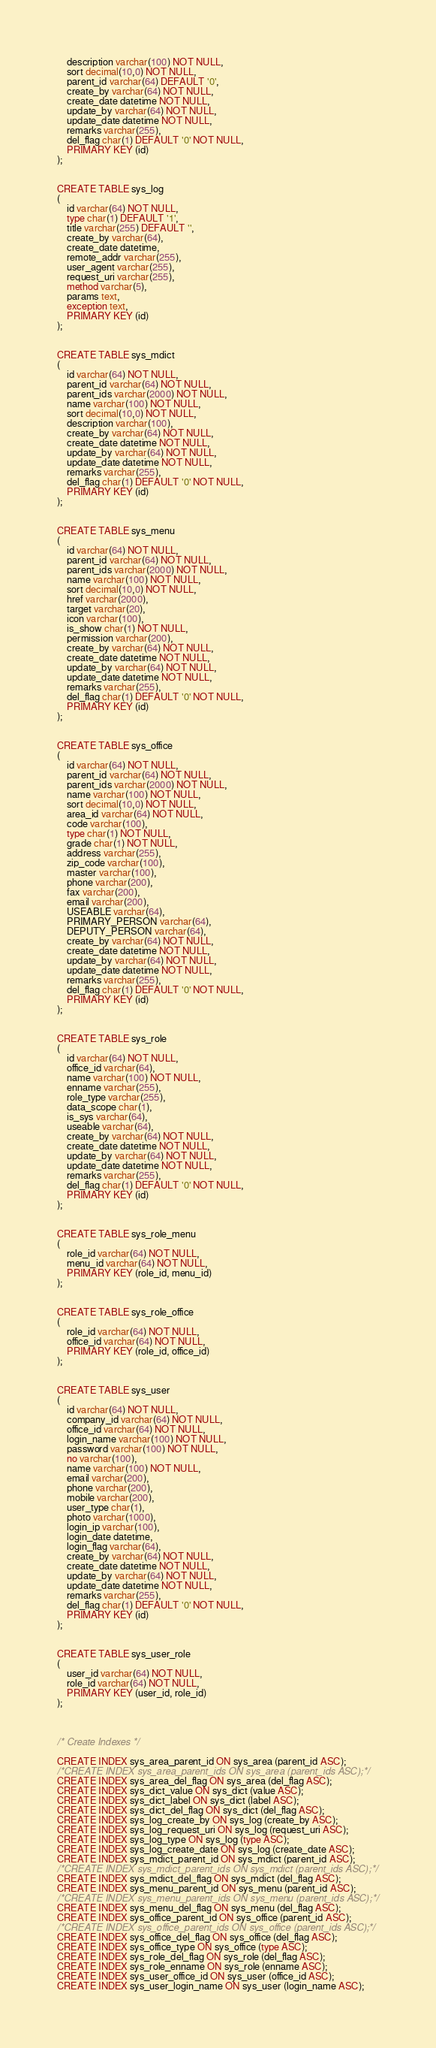<code> <loc_0><loc_0><loc_500><loc_500><_SQL_>	description varchar(100) NOT NULL,
	sort decimal(10,0) NOT NULL,
	parent_id varchar(64) DEFAULT '0',
	create_by varchar(64) NOT NULL,
	create_date datetime NOT NULL,
	update_by varchar(64) NOT NULL,
	update_date datetime NOT NULL,
	remarks varchar(255),
	del_flag char(1) DEFAULT '0' NOT NULL,
	PRIMARY KEY (id)
);


CREATE TABLE sys_log
(
	id varchar(64) NOT NULL,
	type char(1) DEFAULT '1',
	title varchar(255) DEFAULT '',
	create_by varchar(64),
	create_date datetime,
	remote_addr varchar(255),
	user_agent varchar(255),
	request_uri varchar(255),
	method varchar(5),
	params text,
	exception text,
	PRIMARY KEY (id)
);


CREATE TABLE sys_mdict
(
	id varchar(64) NOT NULL,
	parent_id varchar(64) NOT NULL,
	parent_ids varchar(2000) NOT NULL,
	name varchar(100) NOT NULL,
	sort decimal(10,0) NOT NULL,
	description varchar(100),
	create_by varchar(64) NOT NULL,
	create_date datetime NOT NULL,
	update_by varchar(64) NOT NULL,
	update_date datetime NOT NULL,
	remarks varchar(255),
	del_flag char(1) DEFAULT '0' NOT NULL,
	PRIMARY KEY (id)
);


CREATE TABLE sys_menu
(
	id varchar(64) NOT NULL,
	parent_id varchar(64) NOT NULL,
	parent_ids varchar(2000) NOT NULL,
	name varchar(100) NOT NULL,
	sort decimal(10,0) NOT NULL,
	href varchar(2000),
	target varchar(20),
	icon varchar(100),
	is_show char(1) NOT NULL,
	permission varchar(200),
	create_by varchar(64) NOT NULL,
	create_date datetime NOT NULL,
	update_by varchar(64) NOT NULL,
	update_date datetime NOT NULL,
	remarks varchar(255),
	del_flag char(1) DEFAULT '0' NOT NULL,
	PRIMARY KEY (id)
);


CREATE TABLE sys_office
(
	id varchar(64) NOT NULL,
	parent_id varchar(64) NOT NULL,
	parent_ids varchar(2000) NOT NULL,
	name varchar(100) NOT NULL,
	sort decimal(10,0) NOT NULL,
	area_id varchar(64) NOT NULL,
	code varchar(100),
	type char(1) NOT NULL,
	grade char(1) NOT NULL,
	address varchar(255),
	zip_code varchar(100),
	master varchar(100),
	phone varchar(200),
	fax varchar(200),
	email varchar(200),
	USEABLE varchar(64),
	PRIMARY_PERSON varchar(64),
	DEPUTY_PERSON varchar(64),
	create_by varchar(64) NOT NULL,
	create_date datetime NOT NULL,
	update_by varchar(64) NOT NULL,
	update_date datetime NOT NULL,
	remarks varchar(255),
	del_flag char(1) DEFAULT '0' NOT NULL,
	PRIMARY KEY (id)
);


CREATE TABLE sys_role
(
	id varchar(64) NOT NULL,
	office_id varchar(64),
	name varchar(100) NOT NULL,
	enname varchar(255),
	role_type varchar(255),
	data_scope char(1),
	is_sys varchar(64),
	useable varchar(64),
	create_by varchar(64) NOT NULL,
	create_date datetime NOT NULL,
	update_by varchar(64) NOT NULL,
	update_date datetime NOT NULL,
	remarks varchar(255),
	del_flag char(1) DEFAULT '0' NOT NULL,
	PRIMARY KEY (id)
);


CREATE TABLE sys_role_menu
(
	role_id varchar(64) NOT NULL,
	menu_id varchar(64) NOT NULL,
	PRIMARY KEY (role_id, menu_id)
);


CREATE TABLE sys_role_office
(
	role_id varchar(64) NOT NULL,
	office_id varchar(64) NOT NULL,
	PRIMARY KEY (role_id, office_id)
);


CREATE TABLE sys_user
(
	id varchar(64) NOT NULL,
	company_id varchar(64) NOT NULL,
	office_id varchar(64) NOT NULL,
	login_name varchar(100) NOT NULL,
	password varchar(100) NOT NULL,
	no varchar(100),
	name varchar(100) NOT NULL,
	email varchar(200),
	phone varchar(200),
	mobile varchar(200),
	user_type char(1),
	photo varchar(1000),
	login_ip varchar(100),
	login_date datetime,
	login_flag varchar(64),
	create_by varchar(64) NOT NULL,
	create_date datetime NOT NULL,
	update_by varchar(64) NOT NULL,
	update_date datetime NOT NULL,
	remarks varchar(255),
	del_flag char(1) DEFAULT '0' NOT NULL,
	PRIMARY KEY (id)
);


CREATE TABLE sys_user_role
(
	user_id varchar(64) NOT NULL,
	role_id varchar(64) NOT NULL,
	PRIMARY KEY (user_id, role_id)
);



/* Create Indexes */

CREATE INDEX sys_area_parent_id ON sys_area (parent_id ASC);
/*CREATE INDEX sys_area_parent_ids ON sys_area (parent_ids ASC);*/
CREATE INDEX sys_area_del_flag ON sys_area (del_flag ASC);
CREATE INDEX sys_dict_value ON sys_dict (value ASC);
CREATE INDEX sys_dict_label ON sys_dict (label ASC);
CREATE INDEX sys_dict_del_flag ON sys_dict (del_flag ASC);
CREATE INDEX sys_log_create_by ON sys_log (create_by ASC);
CREATE INDEX sys_log_request_uri ON sys_log (request_uri ASC);
CREATE INDEX sys_log_type ON sys_log (type ASC);
CREATE INDEX sys_log_create_date ON sys_log (create_date ASC);
CREATE INDEX sys_mdict_parent_id ON sys_mdict (parent_id ASC);
/*CREATE INDEX sys_mdict_parent_ids ON sys_mdict (parent_ids ASC);*/
CREATE INDEX sys_mdict_del_flag ON sys_mdict (del_flag ASC);
CREATE INDEX sys_menu_parent_id ON sys_menu (parent_id ASC);
/*CREATE INDEX sys_menu_parent_ids ON sys_menu (parent_ids ASC);*/
CREATE INDEX sys_menu_del_flag ON sys_menu (del_flag ASC);
CREATE INDEX sys_office_parent_id ON sys_office (parent_id ASC);
/*CREATE INDEX sys_office_parent_ids ON sys_office (parent_ids ASC);*/
CREATE INDEX sys_office_del_flag ON sys_office (del_flag ASC);
CREATE INDEX sys_office_type ON sys_office (type ASC);
CREATE INDEX sys_role_del_flag ON sys_role (del_flag ASC);
CREATE INDEX sys_role_enname ON sys_role (enname ASC);
CREATE INDEX sys_user_office_id ON sys_user (office_id ASC);
CREATE INDEX sys_user_login_name ON sys_user (login_name ASC);</code> 